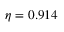Convert formula to latex. <formula><loc_0><loc_0><loc_500><loc_500>\eta = 0 . 9 1 4</formula> 